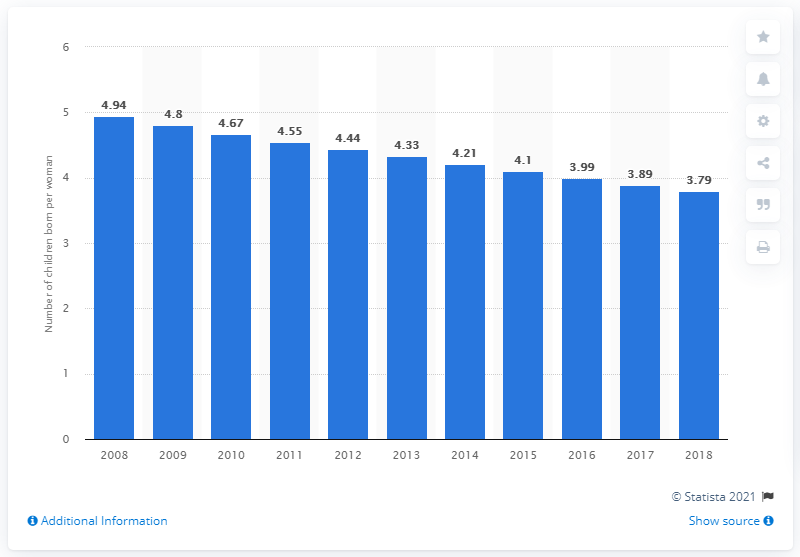Highlight a few significant elements in this photo. In 2018, the fertility rate in Yemen was 3.79. 